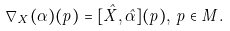Convert formula to latex. <formula><loc_0><loc_0><loc_500><loc_500>\nabla _ { X } ( \alpha ) ( p ) = [ \hat { X } , \hat { \alpha } ] ( p ) , \, p \in M .</formula> 